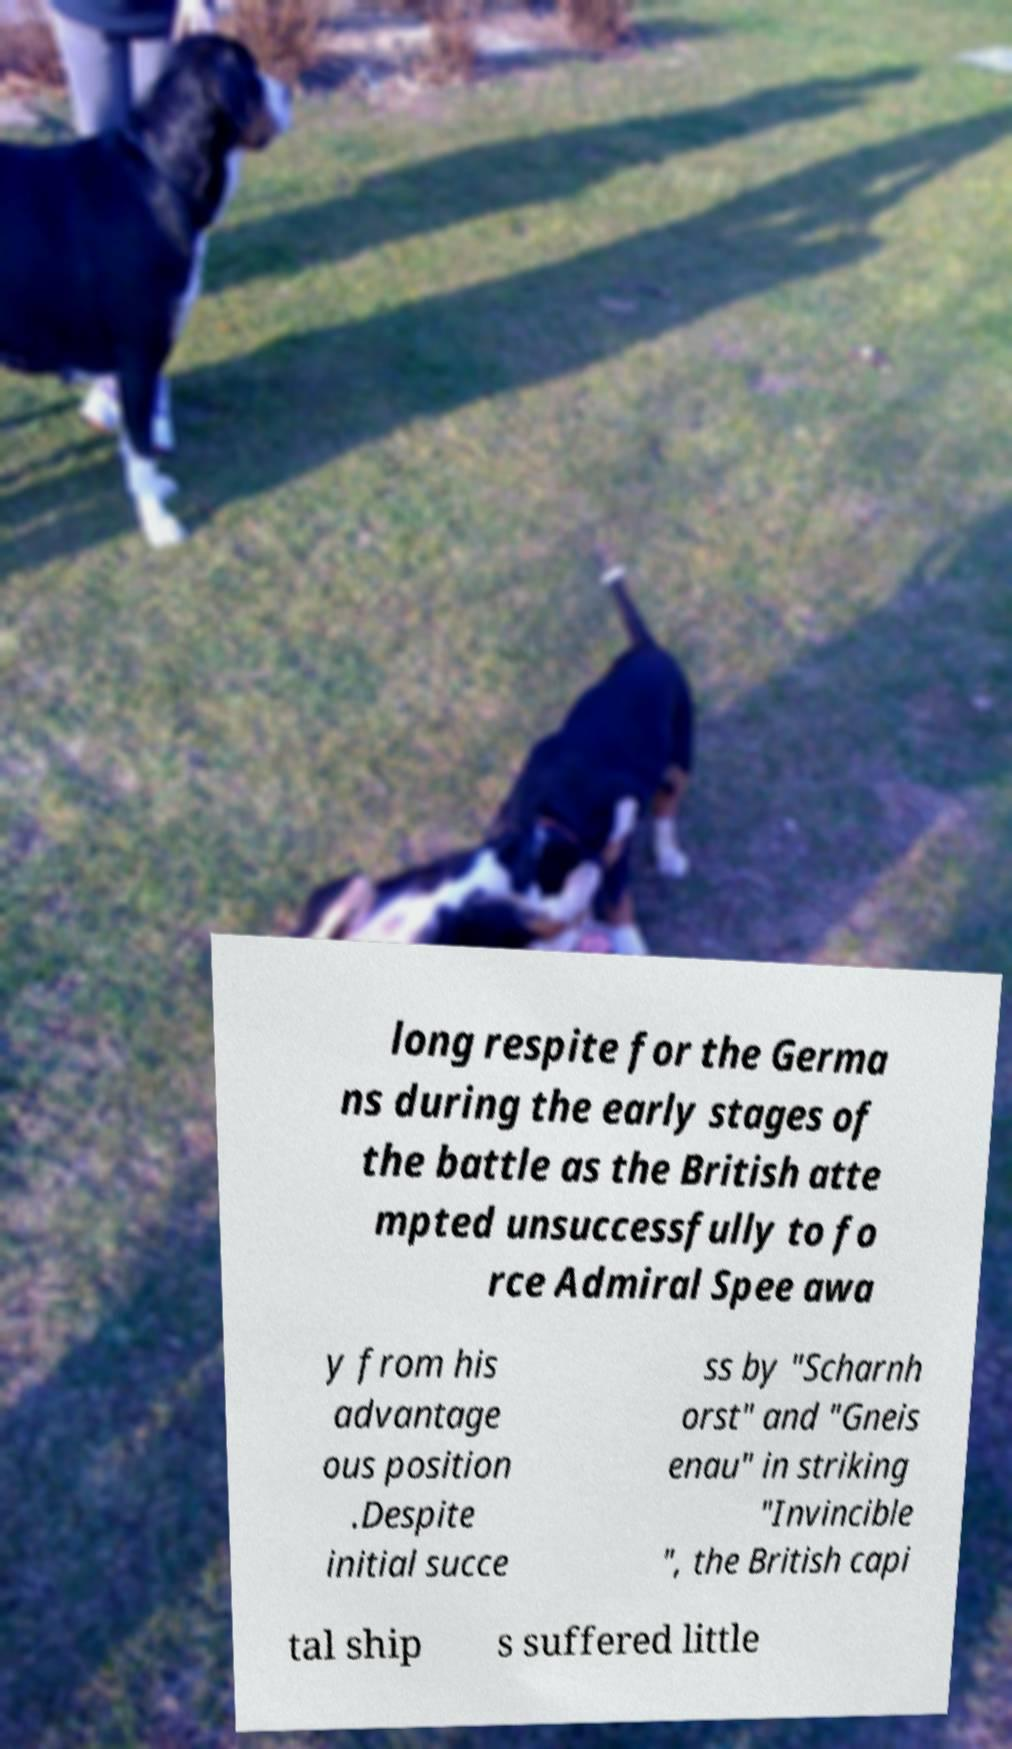There's text embedded in this image that I need extracted. Can you transcribe it verbatim? long respite for the Germa ns during the early stages of the battle as the British atte mpted unsuccessfully to fo rce Admiral Spee awa y from his advantage ous position .Despite initial succe ss by "Scharnh orst" and "Gneis enau" in striking "Invincible ", the British capi tal ship s suffered little 